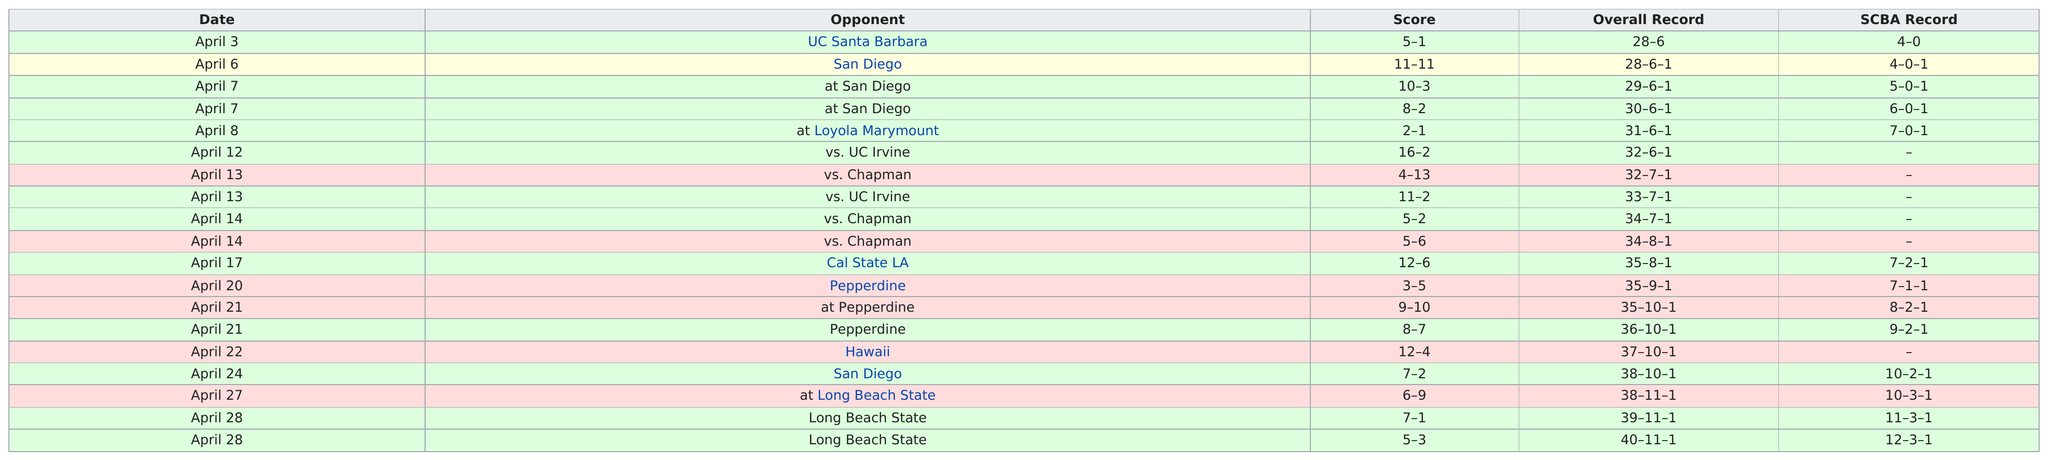Specify some key components in this picture. The Cal State Fullerton baseball team did not defeat any team more than three times during the 1979 season, except for San Diego. In how many games did they win by a margin of at least 5 points? The answer is 8 games. The greatest difference in scores is 9. On or after April 8th, the next time a SCBA record is listed will be April 17th. On April 6, the score was 11 each. 